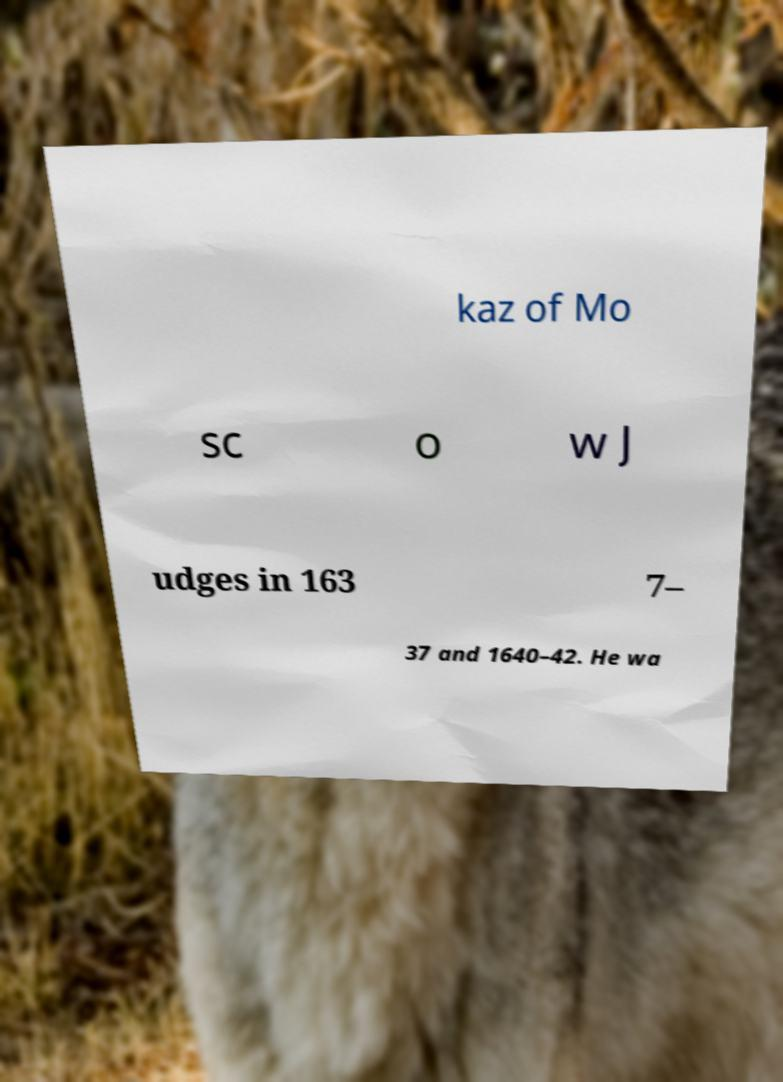For documentation purposes, I need the text within this image transcribed. Could you provide that? kaz of Mo sc o w J udges in 163 7– 37 and 1640–42. He wa 